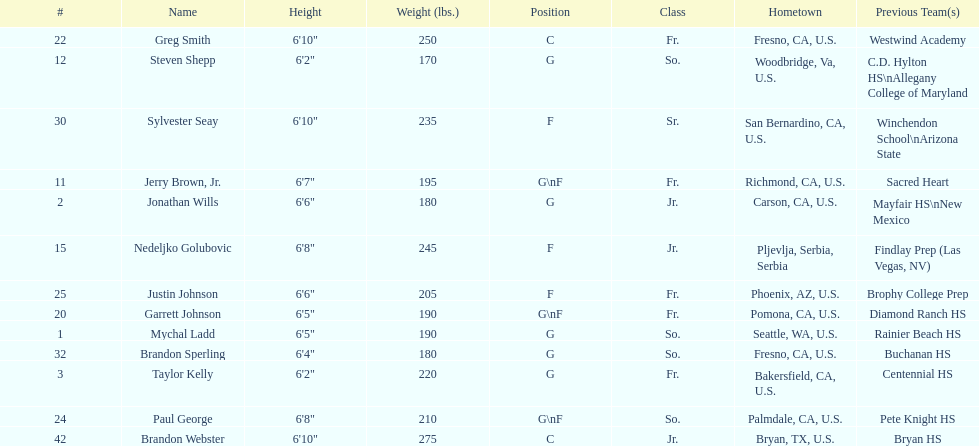Which player is taller, paul george or greg smith? Greg Smith. Would you mind parsing the complete table? {'header': ['#', 'Name', 'Height', 'Weight (lbs.)', 'Position', 'Class', 'Hometown', 'Previous Team(s)'], 'rows': [['22', 'Greg Smith', '6\'10"', '250', 'C', 'Fr.', 'Fresno, CA, U.S.', 'Westwind Academy'], ['12', 'Steven Shepp', '6\'2"', '170', 'G', 'So.', 'Woodbridge, Va, U.S.', 'C.D. Hylton HS\\nAllegany College of Maryland'], ['30', 'Sylvester Seay', '6\'10"', '235', 'F', 'Sr.', 'San Bernardino, CA, U.S.', 'Winchendon School\\nArizona State'], ['11', 'Jerry Brown, Jr.', '6\'7"', '195', 'G\\nF', 'Fr.', 'Richmond, CA, U.S.', 'Sacred Heart'], ['2', 'Jonathan Wills', '6\'6"', '180', 'G', 'Jr.', 'Carson, CA, U.S.', 'Mayfair HS\\nNew Mexico'], ['15', 'Nedeljko Golubovic', '6\'8"', '245', 'F', 'Jr.', 'Pljevlja, Serbia, Serbia', 'Findlay Prep (Las Vegas, NV)'], ['25', 'Justin Johnson', '6\'6"', '205', 'F', 'Fr.', 'Phoenix, AZ, U.S.', 'Brophy College Prep'], ['20', 'Garrett Johnson', '6\'5"', '190', 'G\\nF', 'Fr.', 'Pomona, CA, U.S.', 'Diamond Ranch HS'], ['1', 'Mychal Ladd', '6\'5"', '190', 'G', 'So.', 'Seattle, WA, U.S.', 'Rainier Beach HS'], ['32', 'Brandon Sperling', '6\'4"', '180', 'G', 'So.', 'Fresno, CA, U.S.', 'Buchanan HS'], ['3', 'Taylor Kelly', '6\'2"', '220', 'G', 'Fr.', 'Bakersfield, CA, U.S.', 'Centennial HS'], ['24', 'Paul George', '6\'8"', '210', 'G\\nF', 'So.', 'Palmdale, CA, U.S.', 'Pete Knight HS'], ['42', 'Brandon Webster', '6\'10"', '275', 'C', 'Jr.', 'Bryan, TX, U.S.', 'Bryan HS']]} 